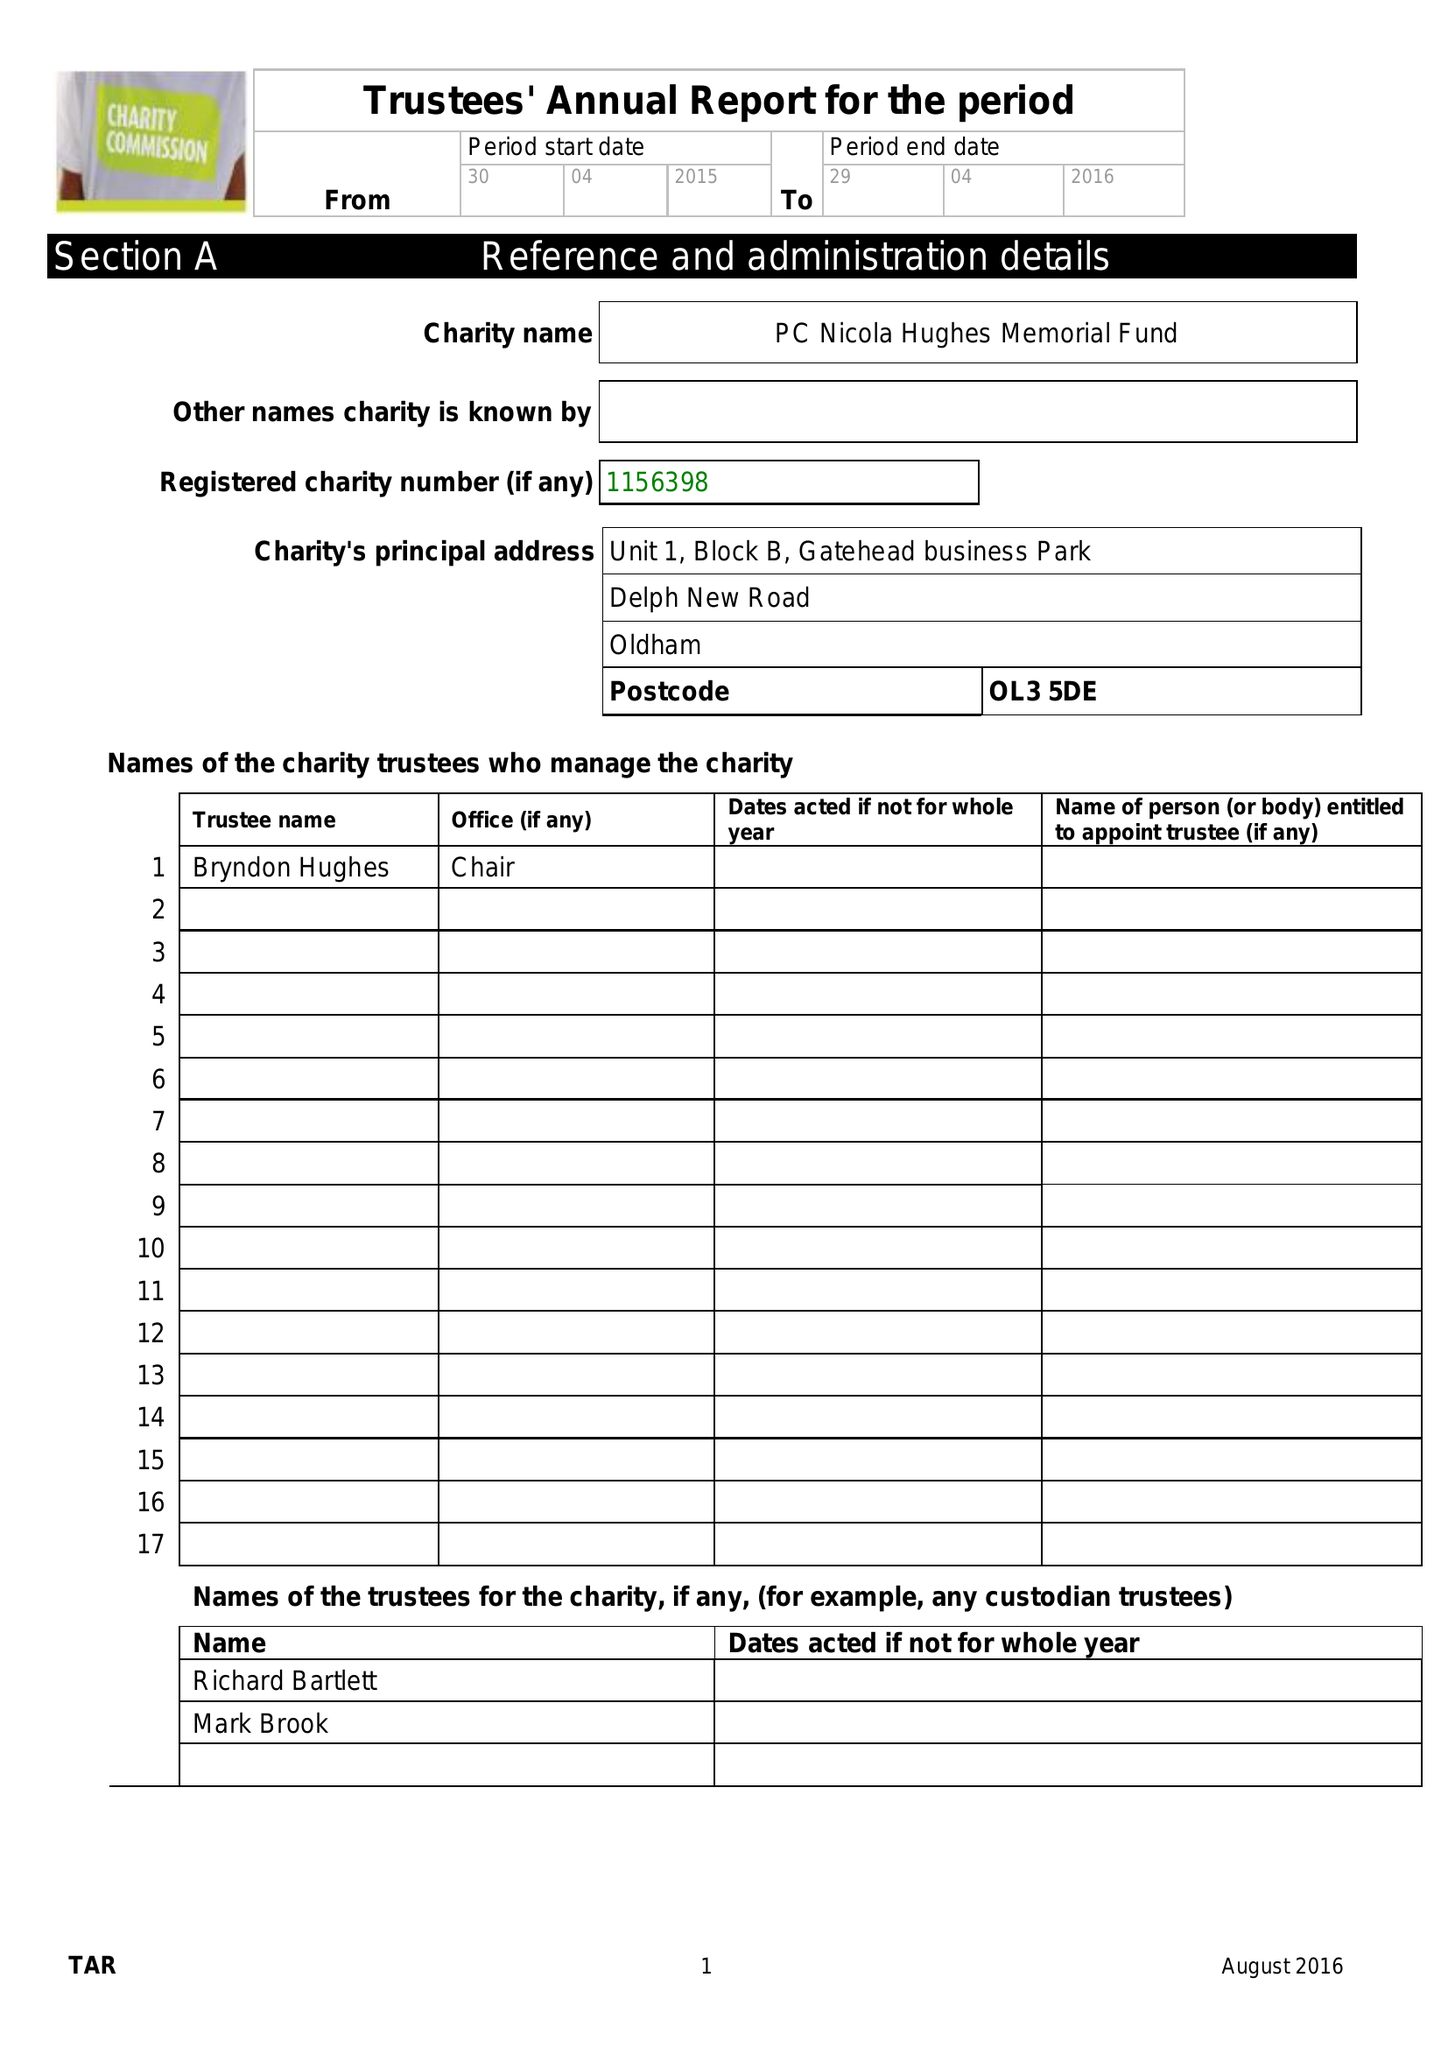What is the value for the charity_number?
Answer the question using a single word or phrase. 1156398 